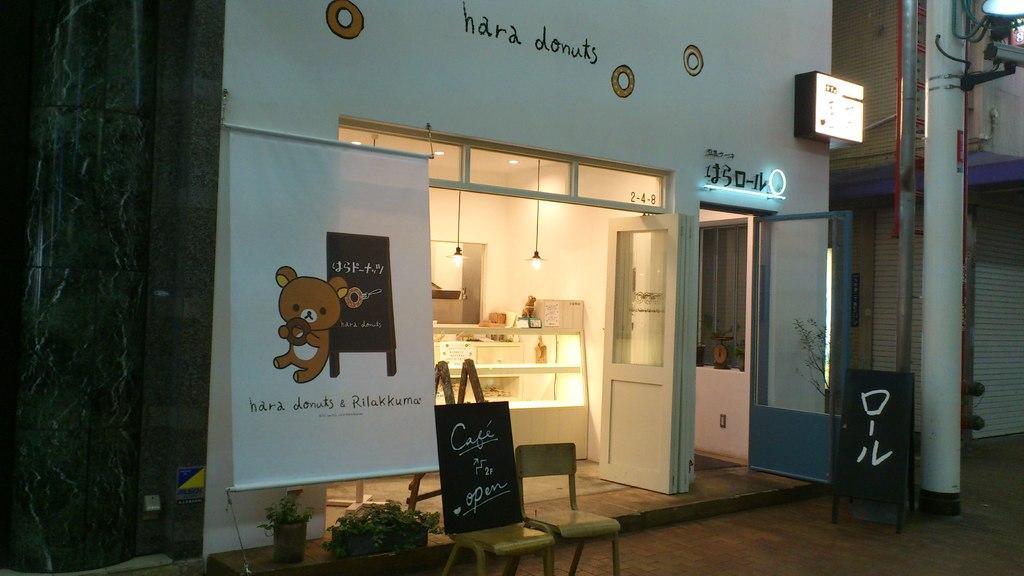Could you give a brief overview of what you see in this image? This is a store. We can see boards near to the store. This is a door. These are lights. Here we can see a street light with a pole. 